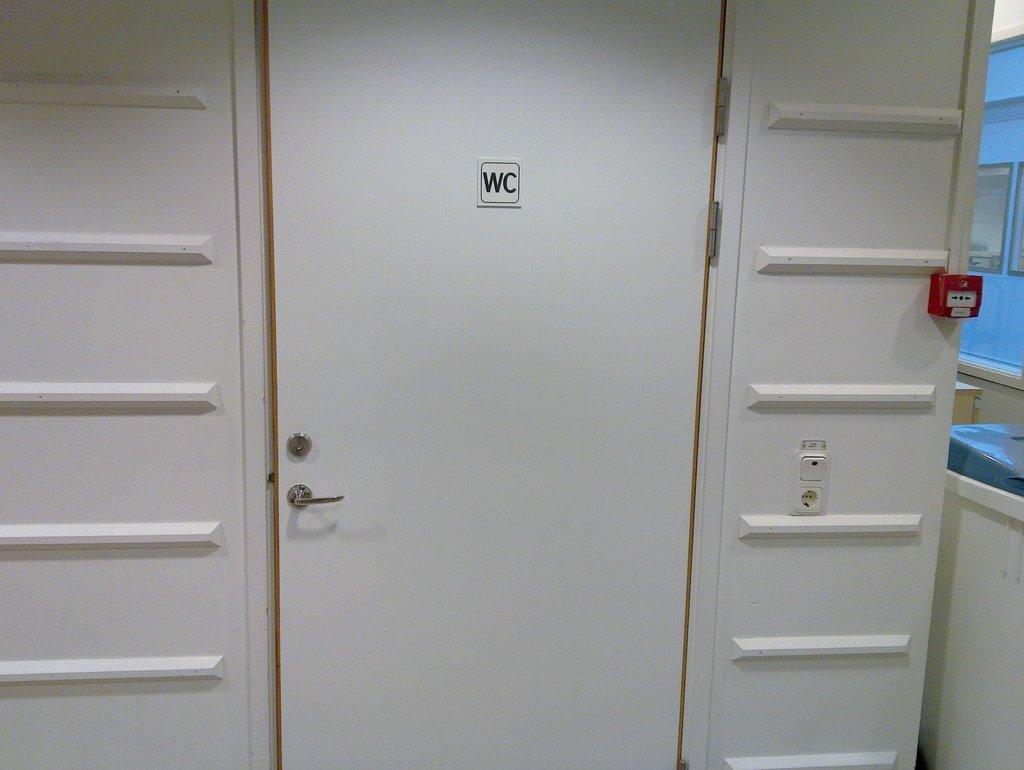What is one of the main features of the image? There is a door in the image. What safety feature can be seen in the image? There is a fire alarm in the image. What type of wrench is being used to tell a story in the image? There is no wrench or storytelling depicted in the image. What color is the silver object in the image? There is no silver object present in the image. 